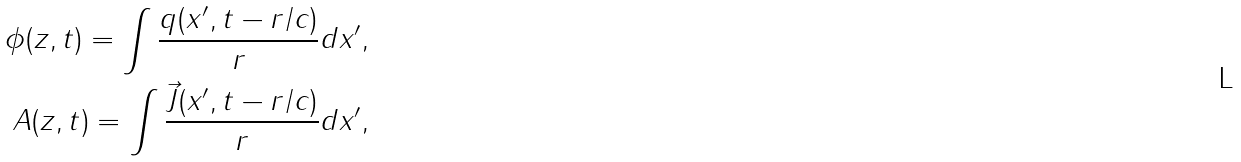<formula> <loc_0><loc_0><loc_500><loc_500>\phi ( z , t ) = \int { \frac { q ( x ^ { \prime } , t - r / c ) } { r } d x ^ { \prime } } , \\ { A } ( z , t ) = \int { \frac { \vec { J } ( x ^ { \prime } , t - r / c ) } { r } d x ^ { \prime } } ,</formula> 